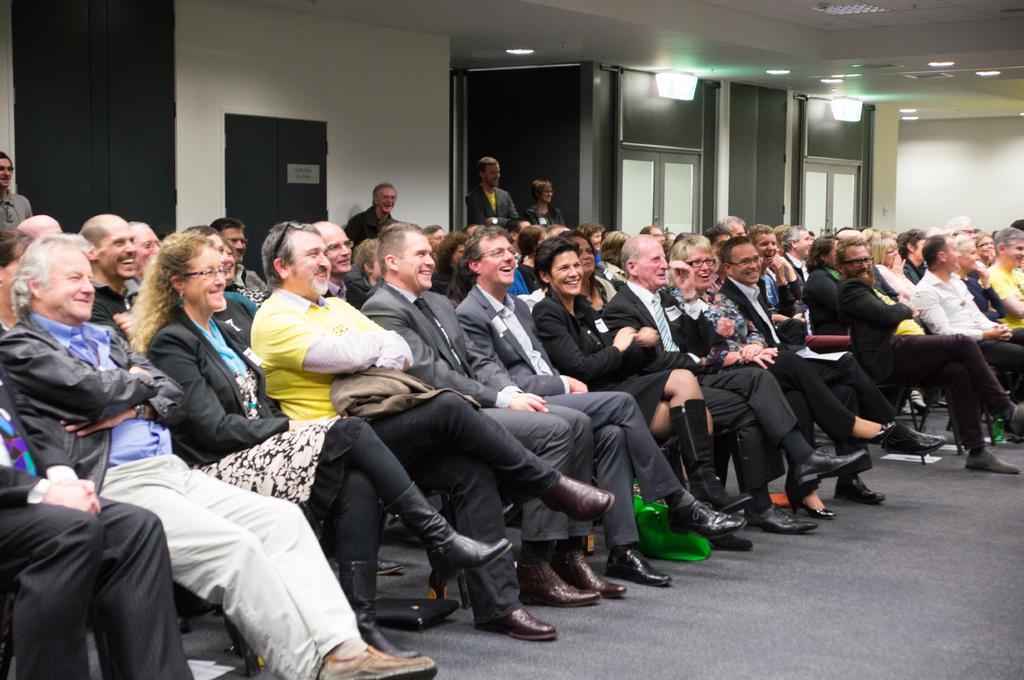Can you describe this image briefly? In this image we can see these people are sitting on the chairs and smiling. In the background, we can see these four persons are standing and smiling, we can see the wall, doors and the ceiling lights. 